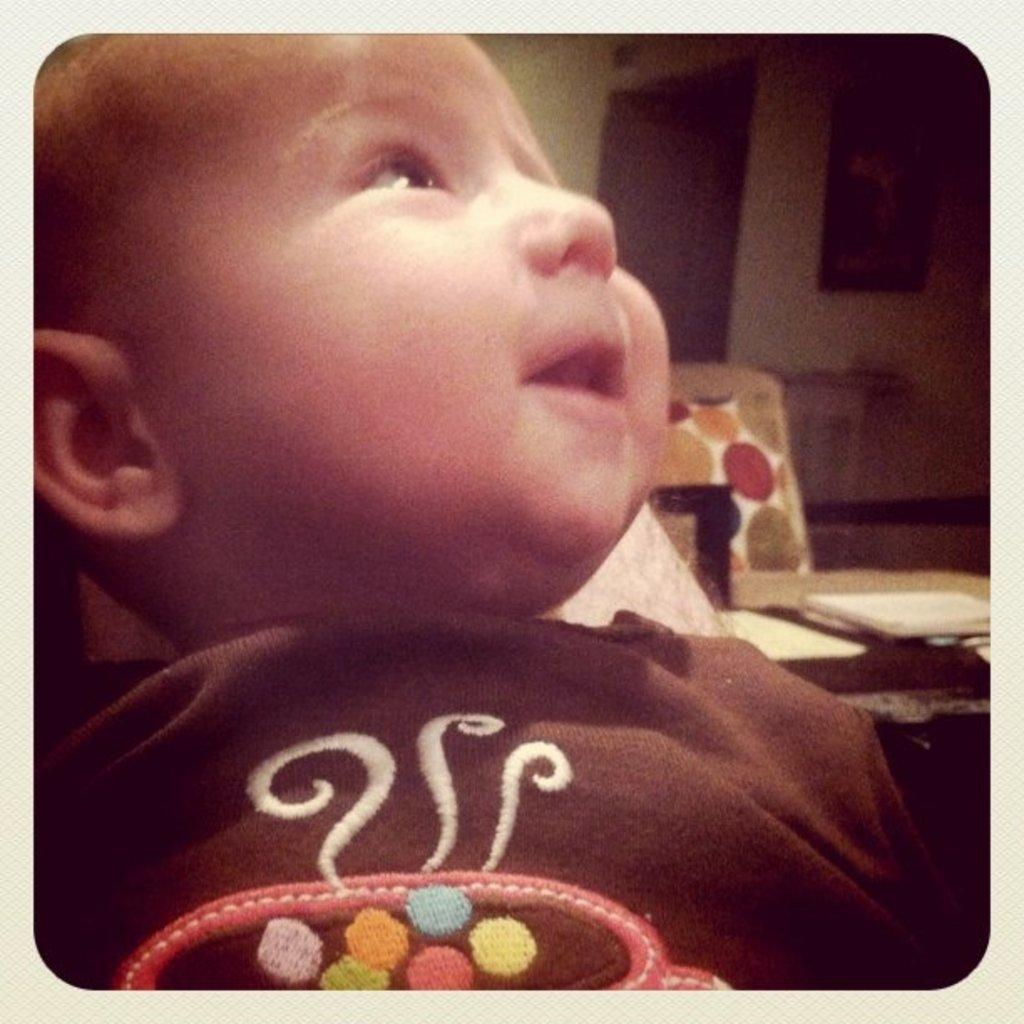What is the main subject in the foreground of the image? There is a baby in the foreground of the image. What furniture can be seen in the background of the image? There is a chair and a table in the background of the image. What is on the table in the background? There are papers and some unspecified objects on the table. What architectural features are visible in the background of the image? There is a wall, a photo frame, and a door in the background of the image. What channel is the baby watching on the TV in the image? There is no TV present in the image; the main subject is a baby in the foreground. How does the lock on the door in the image work? There is no mention of a lock on the door in the image, only the presence of the door itself. 